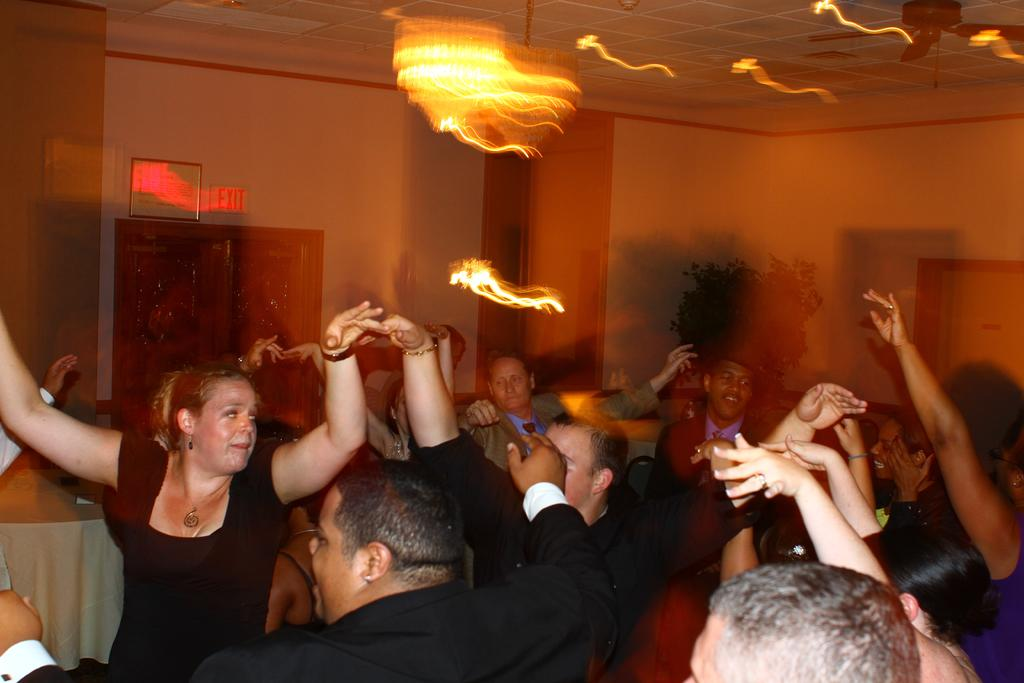How many people are in the image? There is a group of people in the image. What are the people doing in the image? The people are dancing. What can be seen in the background of the image? There are lights visible in the background of the image. What is attached to the wall in the image? There is a frame attached to the wall in the image. How does the ear of the person in the image help them hear the music while dancing? There is no specific person mentioned in the image, and their ears are not visible or discussed in the provided facts. 